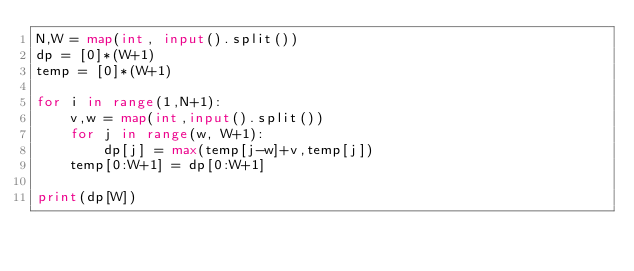<code> <loc_0><loc_0><loc_500><loc_500><_Python_>N,W = map(int, input().split())
dp = [0]*(W+1)
temp = [0]*(W+1)

for i in range(1,N+1):
    v,w = map(int,input().split())
    for j in range(w, W+1):
        dp[j] = max(temp[j-w]+v,temp[j])
    temp[0:W+1] = dp[0:W+1]

print(dp[W])</code> 